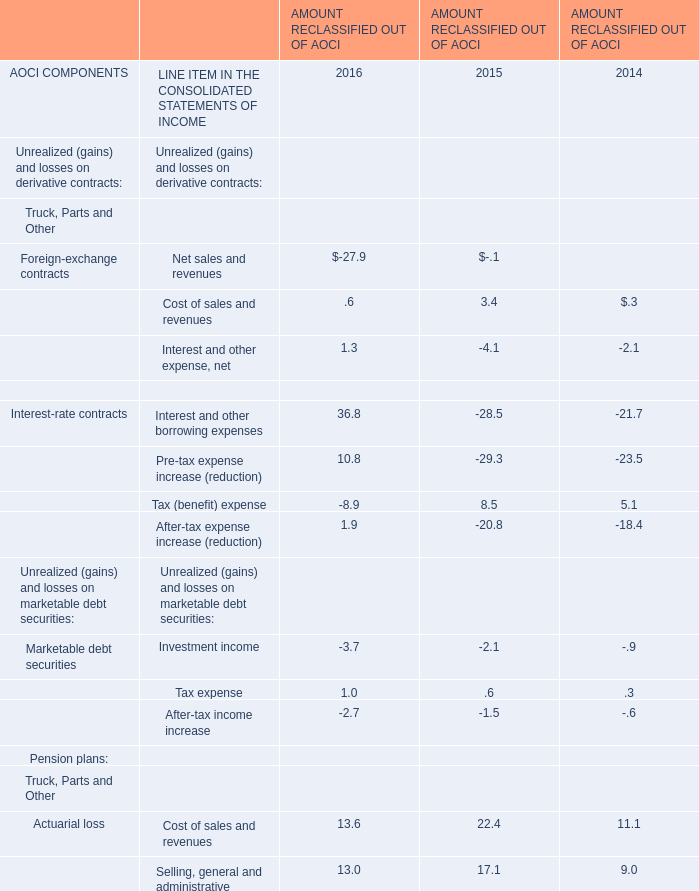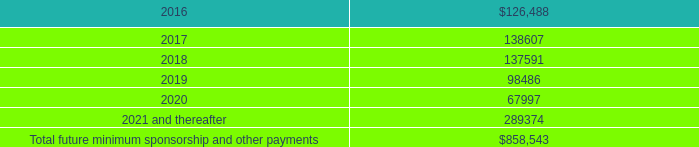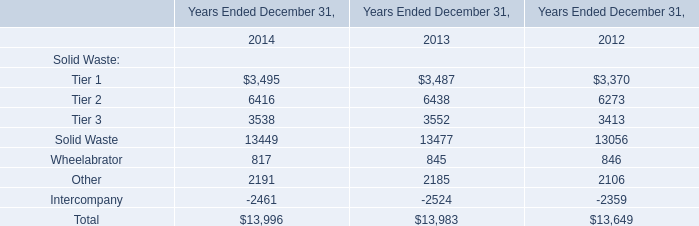What's the total amount of the Solid Waste and Wheelabrator in the years where Cost of sales and revenues is less than 3.4? 
Computations: (13449 + 817)
Answer: 14266.0. 